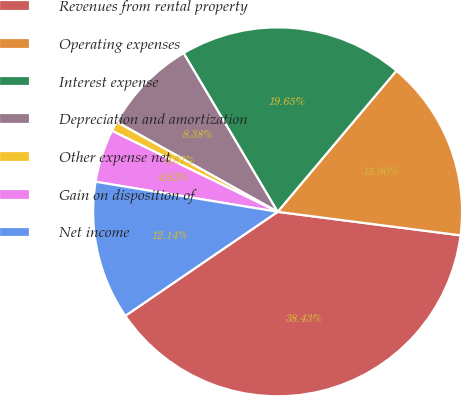<chart> <loc_0><loc_0><loc_500><loc_500><pie_chart><fcel>Revenues from rental property<fcel>Operating expenses<fcel>Interest expense<fcel>Depreciation and amortization<fcel>Other expense net<fcel>Gain on disposition of<fcel>Net income<nl><fcel>38.43%<fcel>15.9%<fcel>19.65%<fcel>8.38%<fcel>0.87%<fcel>4.63%<fcel>12.14%<nl></chart> 